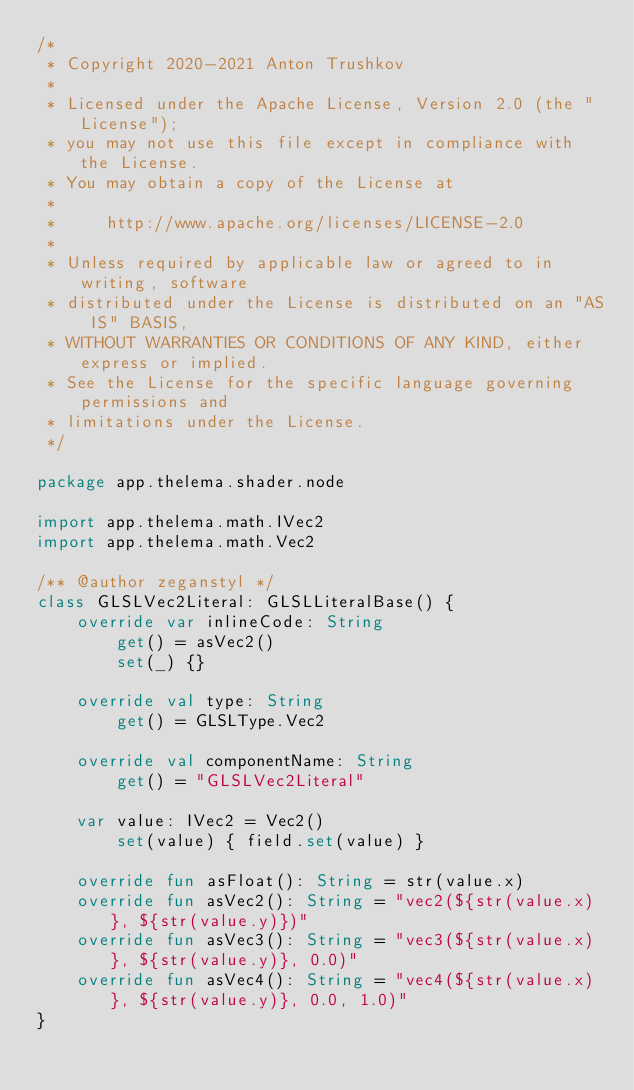<code> <loc_0><loc_0><loc_500><loc_500><_Kotlin_>/*
 * Copyright 2020-2021 Anton Trushkov
 *
 * Licensed under the Apache License, Version 2.0 (the "License");
 * you may not use this file except in compliance with the License.
 * You may obtain a copy of the License at
 *
 *     http://www.apache.org/licenses/LICENSE-2.0
 *
 * Unless required by applicable law or agreed to in writing, software
 * distributed under the License is distributed on an "AS IS" BASIS,
 * WITHOUT WARRANTIES OR CONDITIONS OF ANY KIND, either express or implied.
 * See the License for the specific language governing permissions and
 * limitations under the License.
 */

package app.thelema.shader.node

import app.thelema.math.IVec2
import app.thelema.math.Vec2

/** @author zeganstyl */
class GLSLVec2Literal: GLSLLiteralBase() {
    override var inlineCode: String
        get() = asVec2()
        set(_) {}

    override val type: String
        get() = GLSLType.Vec2

    override val componentName: String
        get() = "GLSLVec2Literal"

    var value: IVec2 = Vec2()
        set(value) { field.set(value) }

    override fun asFloat(): String = str(value.x)
    override fun asVec2(): String = "vec2(${str(value.x)}, ${str(value.y)})"
    override fun asVec3(): String = "vec3(${str(value.x)}, ${str(value.y)}, 0.0)"
    override fun asVec4(): String = "vec4(${str(value.x)}, ${str(value.y)}, 0.0, 1.0)"
}</code> 